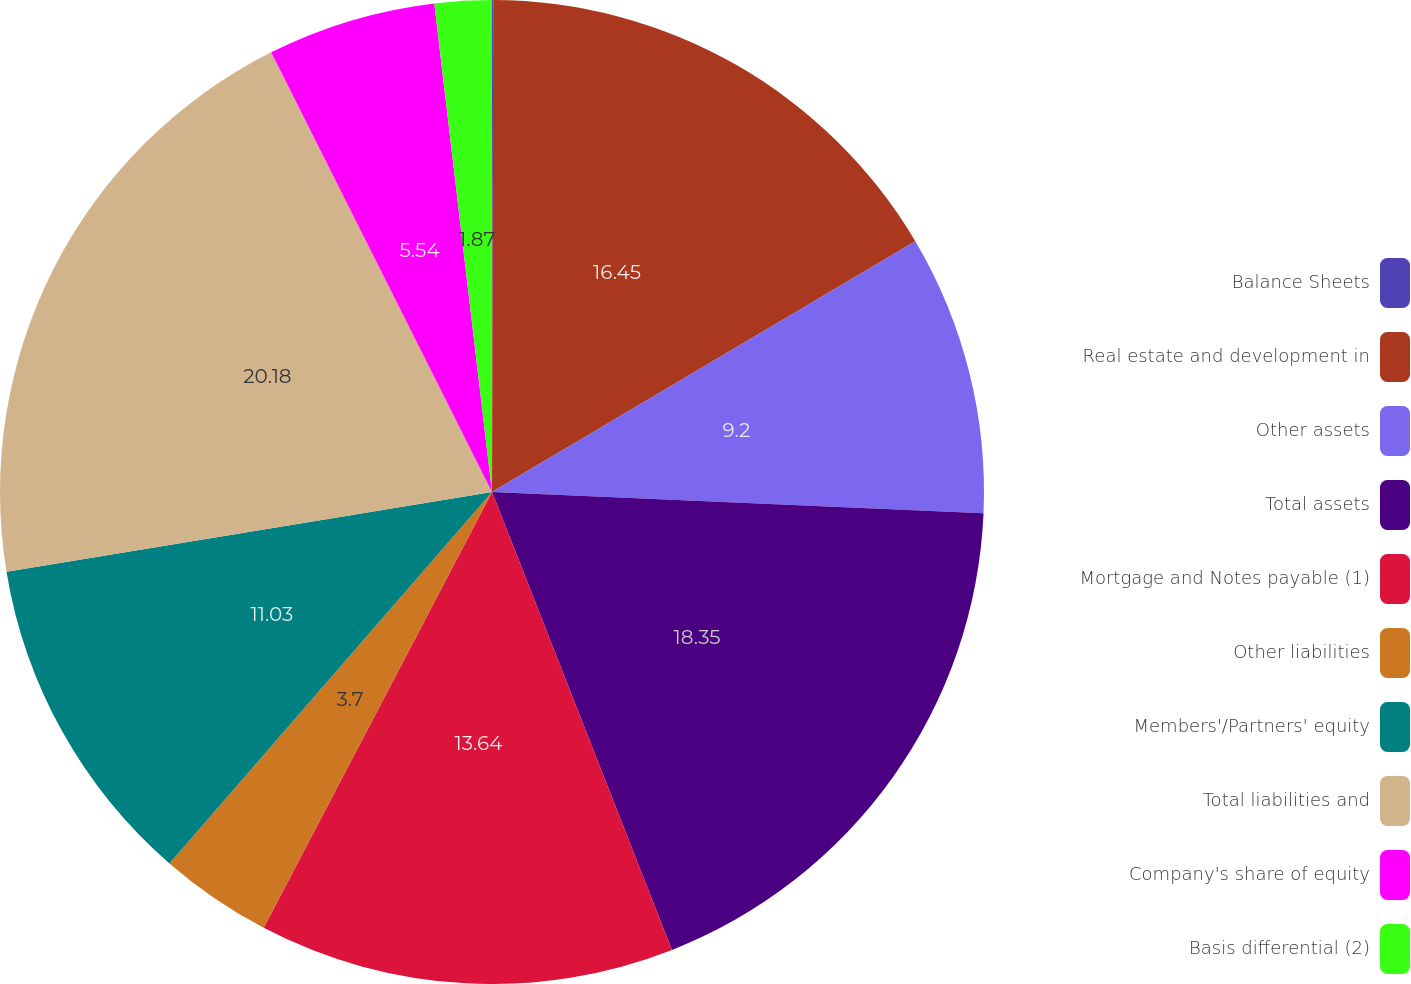<chart> <loc_0><loc_0><loc_500><loc_500><pie_chart><fcel>Balance Sheets<fcel>Real estate and development in<fcel>Other assets<fcel>Total assets<fcel>Mortgage and Notes payable (1)<fcel>Other liabilities<fcel>Members'/Partners' equity<fcel>Total liabilities and<fcel>Company's share of equity<fcel>Basis differential (2)<nl><fcel>0.04%<fcel>16.45%<fcel>9.2%<fcel>18.35%<fcel>13.64%<fcel>3.7%<fcel>11.03%<fcel>20.18%<fcel>5.54%<fcel>1.87%<nl></chart> 